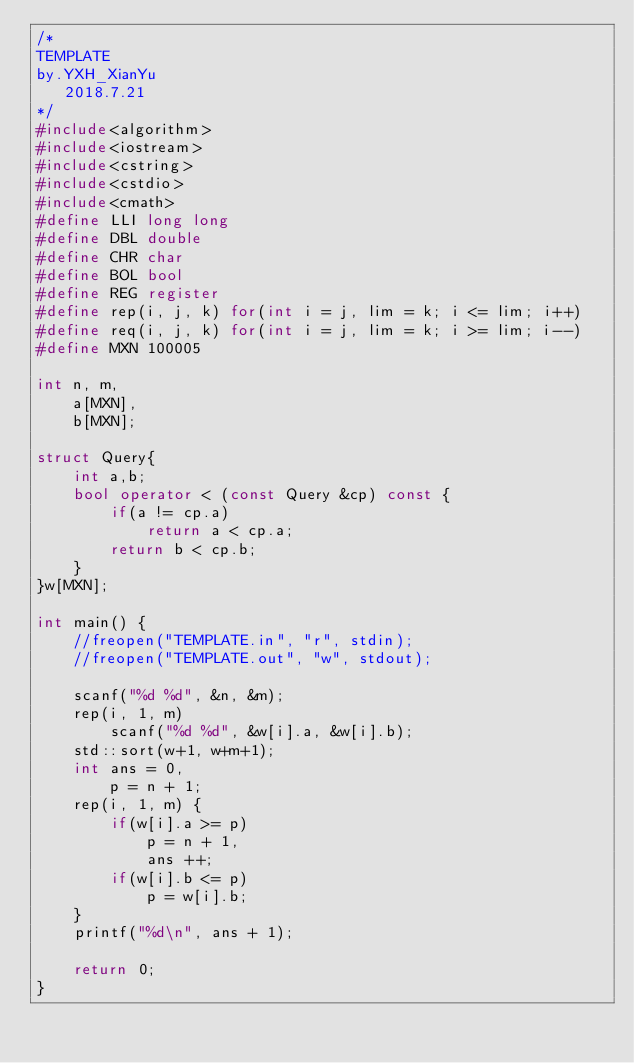<code> <loc_0><loc_0><loc_500><loc_500><_C++_>/*
TEMPLATE
by.YXH_XianYu
   2018.7.21
*/
#include<algorithm>
#include<iostream>
#include<cstring>
#include<cstdio>
#include<cmath>
#define LLI long long
#define DBL double
#define CHR char
#define BOL bool
#define REG register
#define rep(i, j, k) for(int i = j, lim = k; i <= lim; i++)
#define req(i, j, k) for(int i = j, lim = k; i >= lim; i--)
#define MXN 100005

int n, m,
	a[MXN],
	b[MXN];

struct Query{
	int a,b;
	bool operator < (const Query &cp) const {
		if(a != cp.a)
			return a < cp.a;
		return b < cp.b;
	}
}w[MXN];

int main() {
	//freopen("TEMPLATE.in", "r", stdin);
	//freopen("TEMPLATE.out", "w", stdout);
	
	scanf("%d %d", &n, &m);
	rep(i, 1, m)
		scanf("%d %d", &w[i].a, &w[i].b);
	std::sort(w+1, w+m+1);
	int ans = 0,
		p = n + 1;
	rep(i, 1, m) {
		if(w[i].a >= p)
			p = n + 1,
			ans ++;
		if(w[i].b <= p)
			p = w[i].b;
	}
	printf("%d\n", ans + 1);

	return 0;
}</code> 